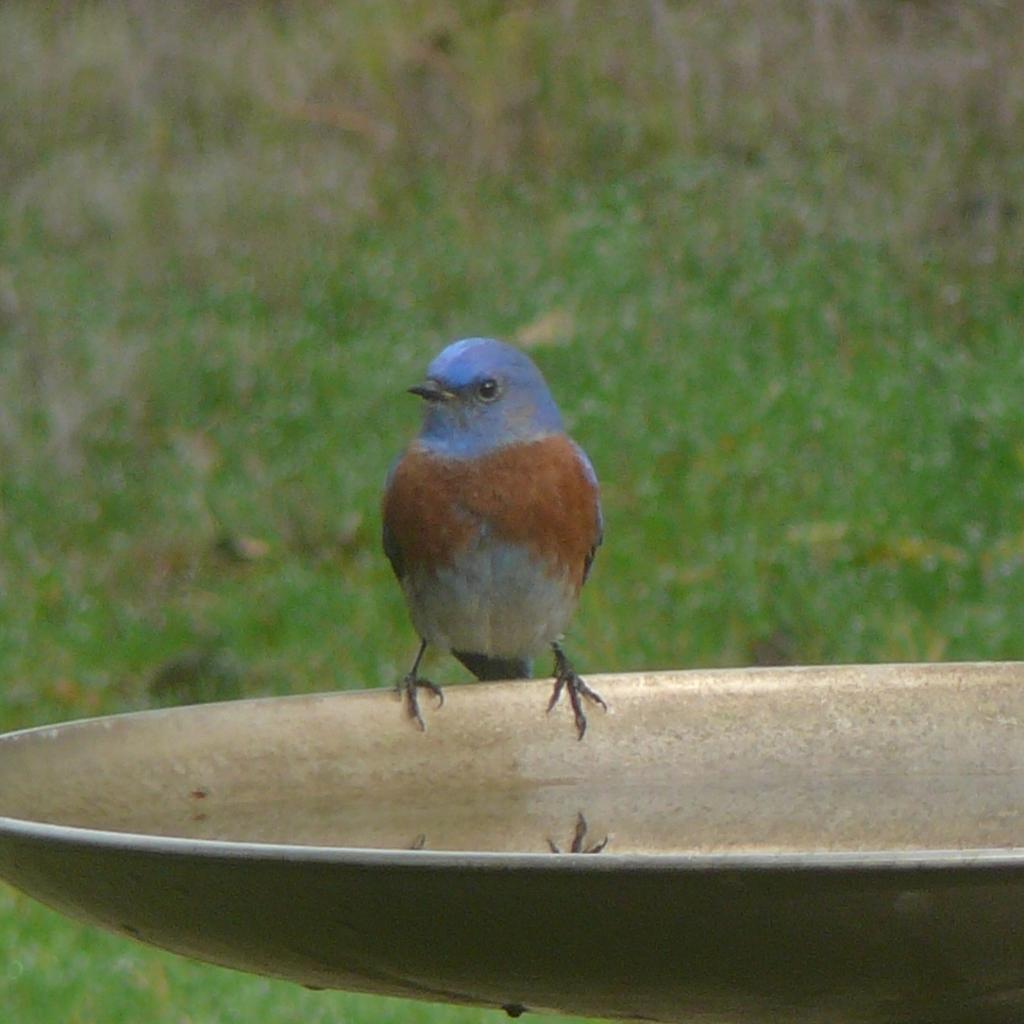Can you describe this image briefly? This image consists of bird sitting on a plate in which there is water. At the bottom, there is green grass. The bird is in blue color. 